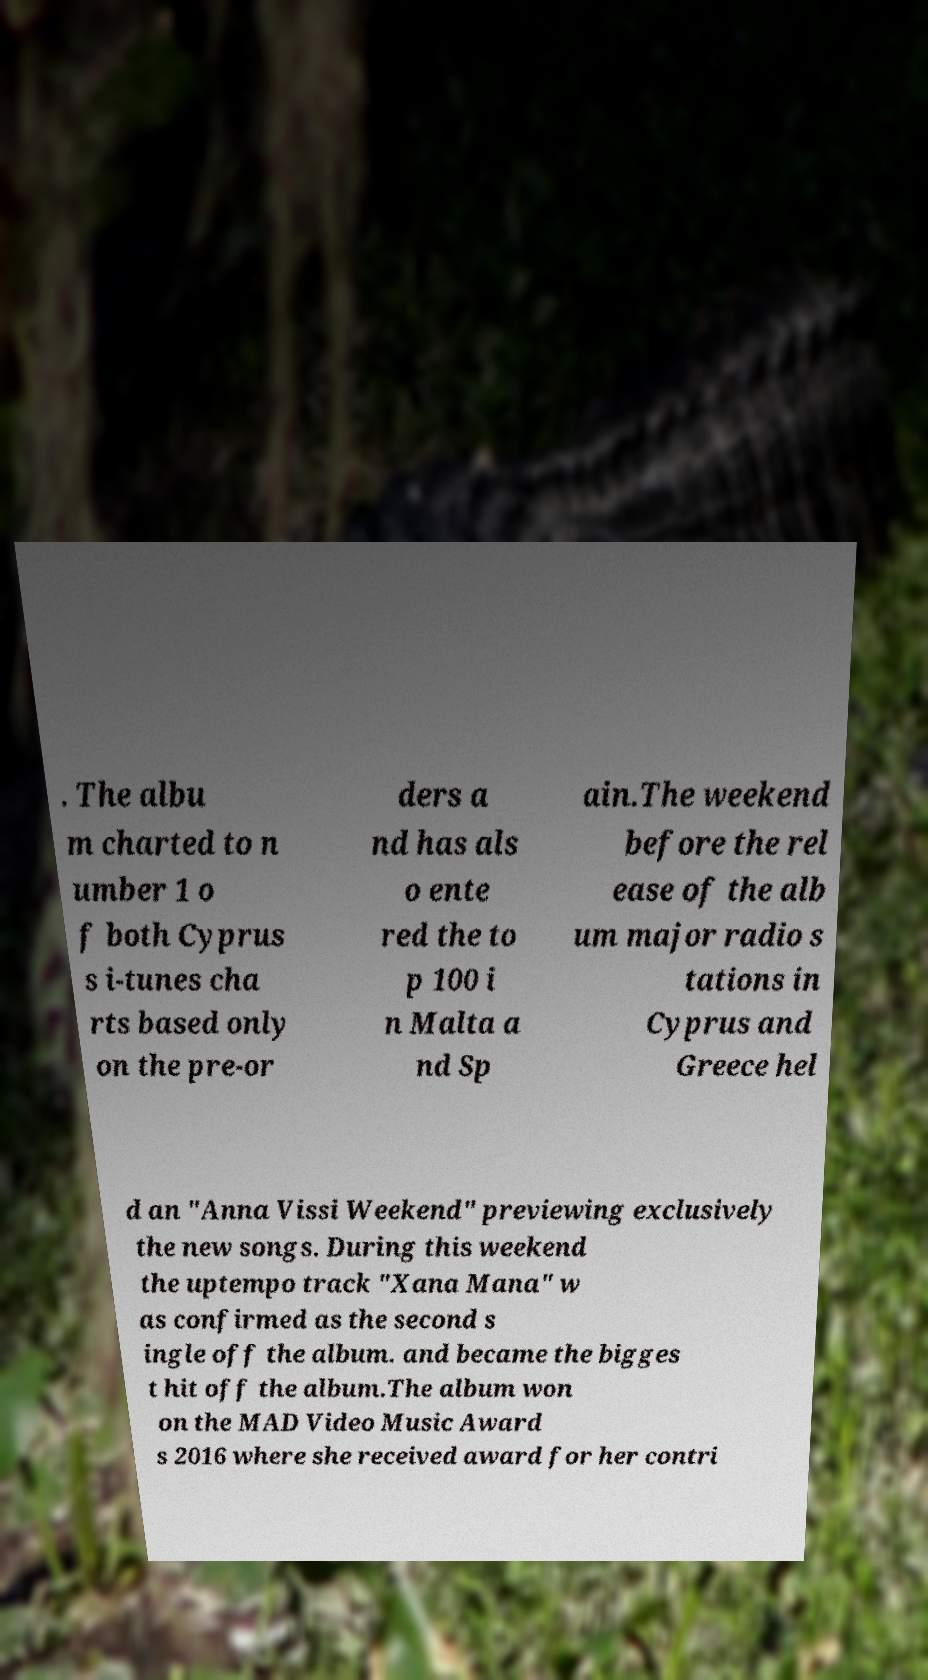Could you assist in decoding the text presented in this image and type it out clearly? . The albu m charted to n umber 1 o f both Cyprus s i-tunes cha rts based only on the pre-or ders a nd has als o ente red the to p 100 i n Malta a nd Sp ain.The weekend before the rel ease of the alb um major radio s tations in Cyprus and Greece hel d an "Anna Vissi Weekend" previewing exclusively the new songs. During this weekend the uptempo track "Xana Mana" w as confirmed as the second s ingle off the album. and became the bigges t hit off the album.The album won on the MAD Video Music Award s 2016 where she received award for her contri 